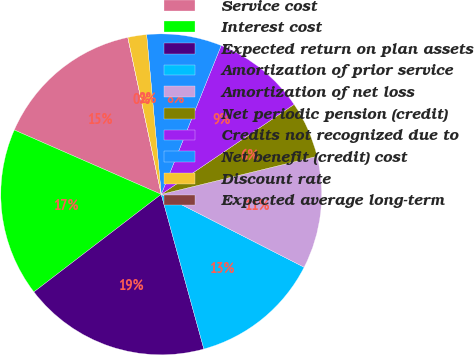Convert chart. <chart><loc_0><loc_0><loc_500><loc_500><pie_chart><fcel>Service cost<fcel>Interest cost<fcel>Expected return on plan assets<fcel>Amortization of prior service<fcel>Amortization of net loss<fcel>Net periodic pension (credit)<fcel>Credits not recognized due to<fcel>Net benefit (credit) cost<fcel>Discount rate<fcel>Expected average long-term<nl><fcel>15.09%<fcel>16.98%<fcel>18.87%<fcel>13.21%<fcel>11.32%<fcel>5.66%<fcel>9.43%<fcel>7.55%<fcel>1.89%<fcel>0.0%<nl></chart> 